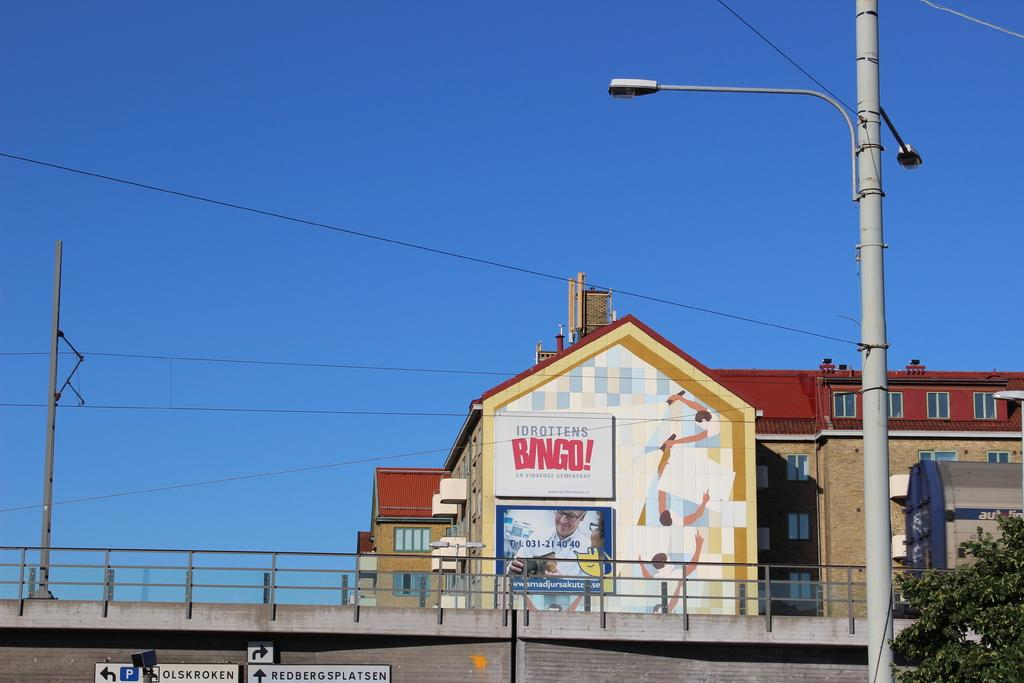What structures are present in the image? There are poles and a bridge with railing in the image. What type of material can be seen in the image? There are boards visible in the image. Where is the tree located in the image? The tree is to the right of the image. What can be seen in the background of the image? There are buildings and the sky visible in the background of the image. What advice is being given by the tree in the image? There is no indication in the image that the tree is giving advice; it is a stationary object in the image. What selection of items can be seen on the bridge in the image? There is no selection of items visible on the bridge in the image; only the bridge, railing, and poles are present. 